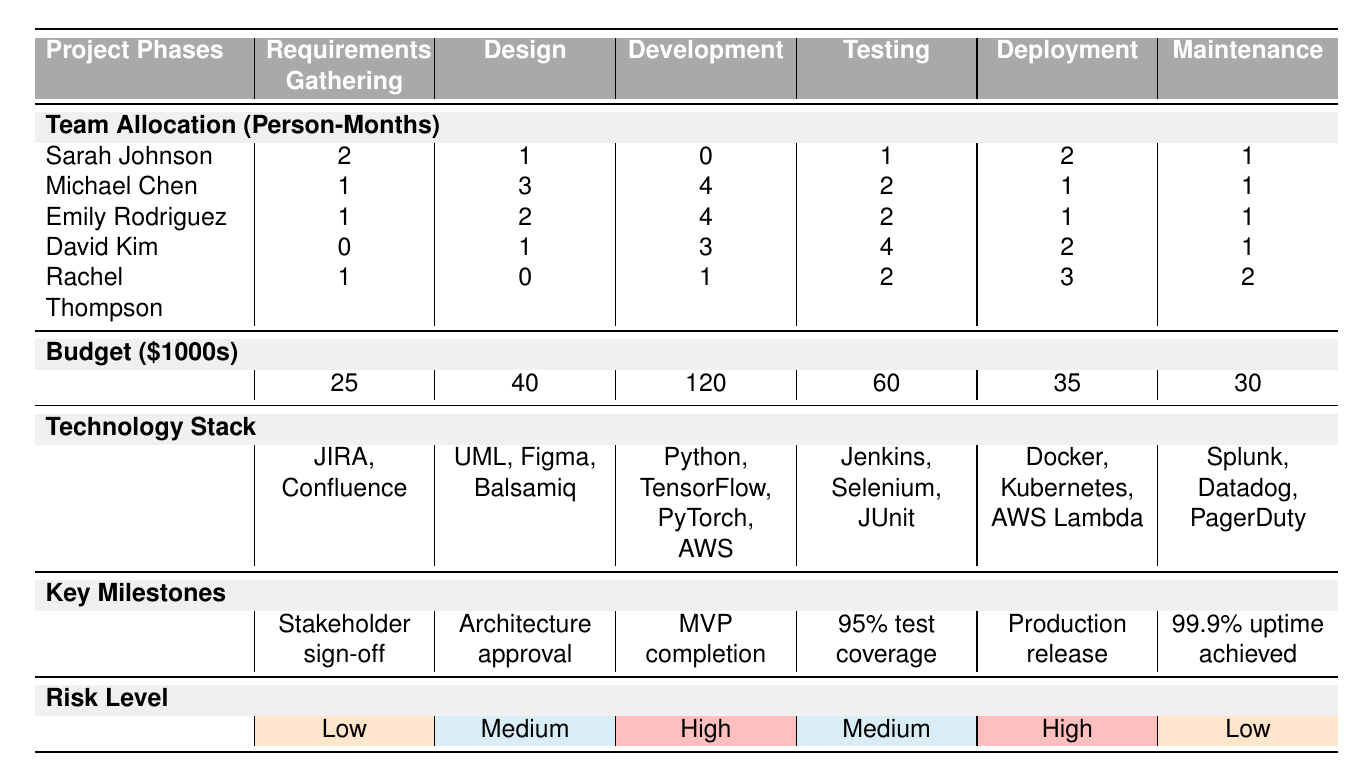What is the total budget for the Development phase? The budget allocated for the Development phase is listed as $120,000.
Answer: $120,000 Who is allocated the most person-months during the Development phase? Michael Chen and Emily Rodriguez each have an allocation of 4 person-months, which is the highest.
Answer: Michael Chen and Emily Rodriguez What is the key milestone for the Testing phase? The key milestone for the Testing phase is "95% test coverage."
Answer: 95% test coverage Which phase has the highest overall risk level? The Development and Deployment phases both have a risk level categorized as "High," which is the highest in the table.
Answer: Development and Deployment What technology is used in the Design phase? The technology stack for the Design phase includes UML, Figma, and Balsamiq.
Answer: UML, Figma, Balsamiq How many total person-months are allocated to the Requirements Gathering phase? The total person-months for the Requirements Gathering phase are obtained by summing Sarah Johnson (2), Michael Chen (1), Emily Rodriguez (1), David Kim (0), and Rachel Thompson (1), resulting in 5 person-months.
Answer: 5 person-months Is the allocated budget greater for the Testing phase than for the Deployment phase? The budget for the Testing phase is $60,000, while for the Deployment phase it is $35,000; thus, Testing has a greater budget allocation.
Answer: Yes What is the average allocation in person-months for all team members in the Maintenance phase? Summing the person-months for Maintenance (1, 1, 1, 1, 2) gives 6, dividing by the 5 team members results in an average of 1.2 person-months allocated for Maintenance.
Answer: 1.2 person-months Which team member has no allocation during the Development phase? Sarah Johnson is allocated 0 person-months during the Development phase.
Answer: Sarah Johnson What is the difference in budget between the Development phase and the Testing phase? The development budget is $120,000 and the testing budget is $60,000, so the difference is $120,000 - $60,000 = $60,000.
Answer: $60,000 